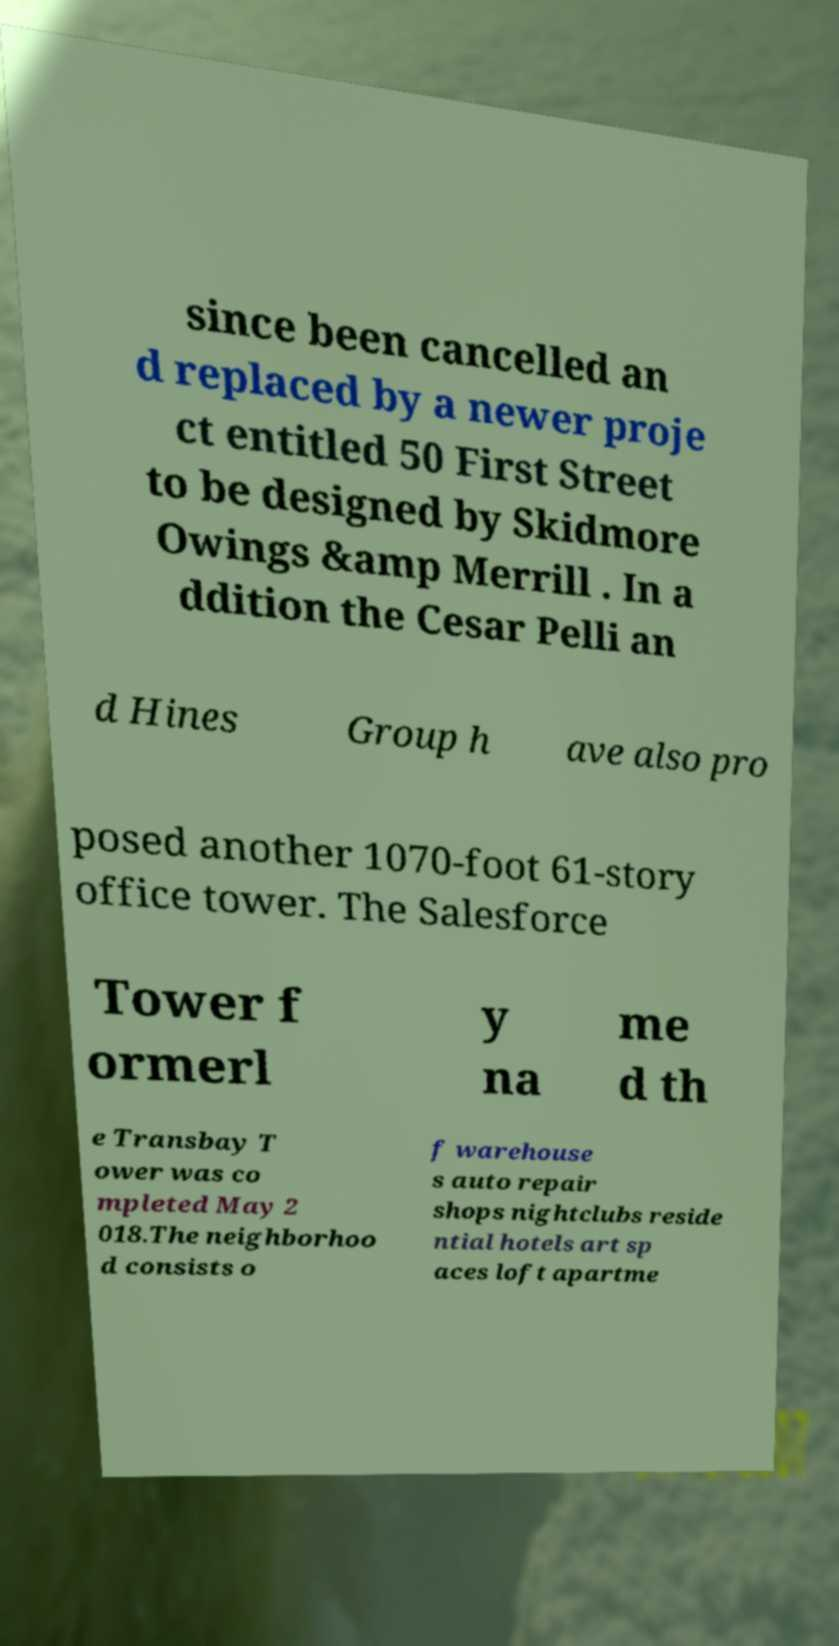For documentation purposes, I need the text within this image transcribed. Could you provide that? since been cancelled an d replaced by a newer proje ct entitled 50 First Street to be designed by Skidmore Owings &amp Merrill . In a ddition the Cesar Pelli an d Hines Group h ave also pro posed another 1070-foot 61-story office tower. The Salesforce Tower f ormerl y na me d th e Transbay T ower was co mpleted May 2 018.The neighborhoo d consists o f warehouse s auto repair shops nightclubs reside ntial hotels art sp aces loft apartme 